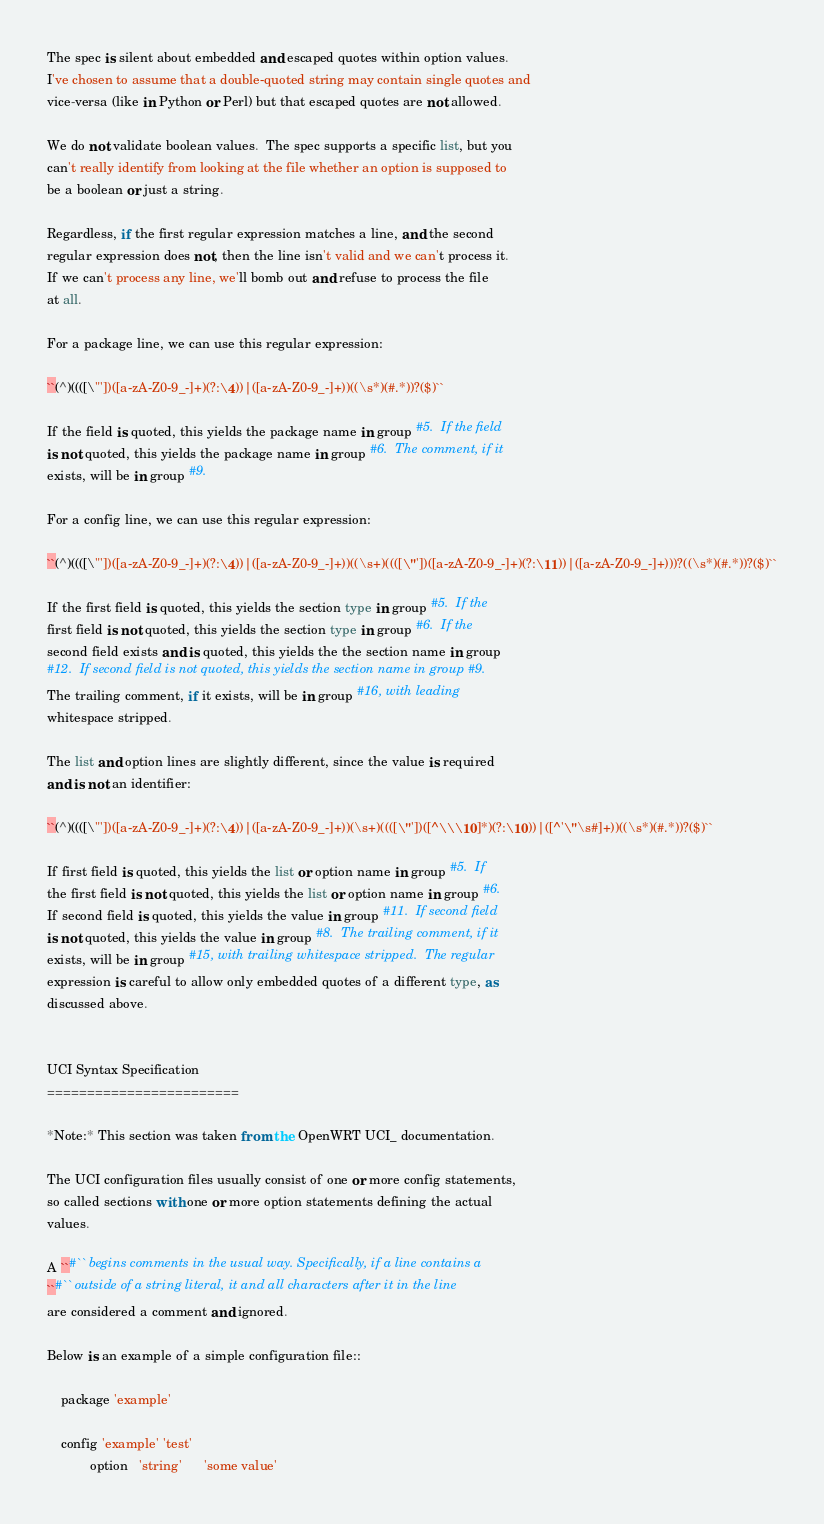<code> <loc_0><loc_0><loc_500><loc_500><_Python_>
The spec is silent about embedded and escaped quotes within option values.
I've chosen to assume that a double-quoted string may contain single quotes and
vice-versa (like in Python or Perl) but that escaped quotes are not allowed.  

We do not validate boolean values.  The spec supports a specific list, but you
can't really identify from looking at the file whether an option is supposed to
be a boolean or just a string. 

Regardless, if the first regular expression matches a line, and the second
regular expression does not, then the line isn't valid and we can't process it.
If we can't process any line, we'll bomb out and refuse to process the file
at all.

For a package line, we can use this regular expression:

``(^)((([\"'])([a-zA-Z0-9_-]+)(?:\4))|([a-zA-Z0-9_-]+))((\s*)(#.*))?($)``

If the field is quoted, this yields the package name in group #5.  If the field
is not quoted, this yields the package name in group #6.  The comment, if it
exists, will be in group #9.

For a config line, we can use this regular expression:

``(^)((([\"'])([a-zA-Z0-9_-]+)(?:\4))|([a-zA-Z0-9_-]+))((\s+)((([\"'])([a-zA-Z0-9_-]+)(?:\11))|([a-zA-Z0-9_-]+)))?((\s*)(#.*))?($)``

If the first field is quoted, this yields the section type in group #5.  If the
first field is not quoted, this yields the section type in group #6.  If the
second field exists and is quoted, this yields the the section name in group
#12.  If second field is not quoted, this yields the section name in group #9.
The trailing comment, if it exists, will be in group #16, with leading
whitespace stripped.

The list and option lines are slightly different, since the value is required
and is not an identifier:

``(^)((([\"'])([a-zA-Z0-9_-]+)(?:\4))|([a-zA-Z0-9_-]+))(\s+)((([\"'])([^\\\10]*)(?:\10))|([^'\"\s#]+))((\s*)(#.*))?($)``

If first field is quoted, this yields the list or option name in group #5.  If
the first field is not quoted, this yields the list or option name in group #6.
If second field is quoted, this yields the value in group #11.  If second field
is not quoted, this yields the value in group #8.  The trailing comment, if it
exists, will be in group #15, with trailing whitespace stripped.  The regular
expression is careful to allow only embedded quotes of a different type, as
discussed above.


UCI Syntax Specification
========================

*Note:* This section was taken from the OpenWRT UCI_ documentation.  

The UCI configuration files usually consist of one or more config statements,
so called sections with one or more option statements defining the actual
values.

A ``#`` begins comments in the usual way. Specifically, if a line contains a
``#`` outside of a string literal, it and all characters after it in the line
are considered a comment and ignored.

Below is an example of a simple configuration file::

    package 'example'
     
    config 'example' 'test'
            option   'string'      'some value'</code> 